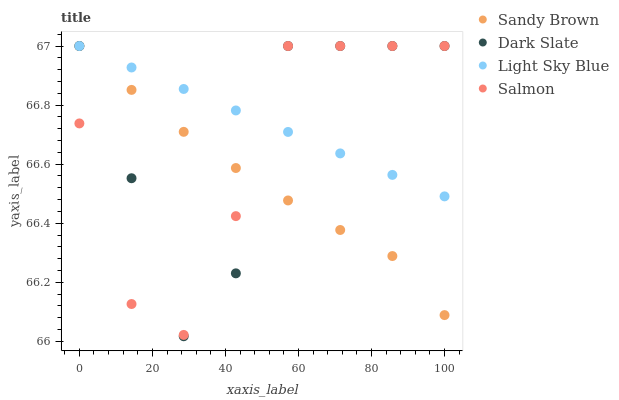Does Sandy Brown have the minimum area under the curve?
Answer yes or no. Yes. Does Light Sky Blue have the maximum area under the curve?
Answer yes or no. Yes. Does Light Sky Blue have the minimum area under the curve?
Answer yes or no. No. Does Sandy Brown have the maximum area under the curve?
Answer yes or no. No. Is Light Sky Blue the smoothest?
Answer yes or no. Yes. Is Dark Slate the roughest?
Answer yes or no. Yes. Is Sandy Brown the smoothest?
Answer yes or no. No. Is Sandy Brown the roughest?
Answer yes or no. No. Does Dark Slate have the lowest value?
Answer yes or no. Yes. Does Sandy Brown have the lowest value?
Answer yes or no. No. Does Salmon have the highest value?
Answer yes or no. Yes. Does Sandy Brown intersect Salmon?
Answer yes or no. Yes. Is Sandy Brown less than Salmon?
Answer yes or no. No. Is Sandy Brown greater than Salmon?
Answer yes or no. No. 